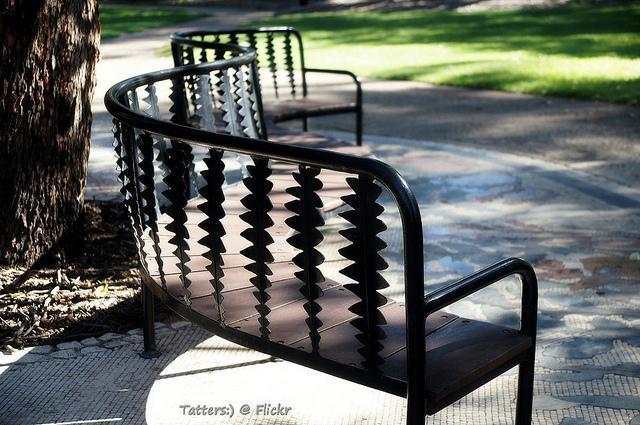How many people are not under an umbrella?
Give a very brief answer. 0. 